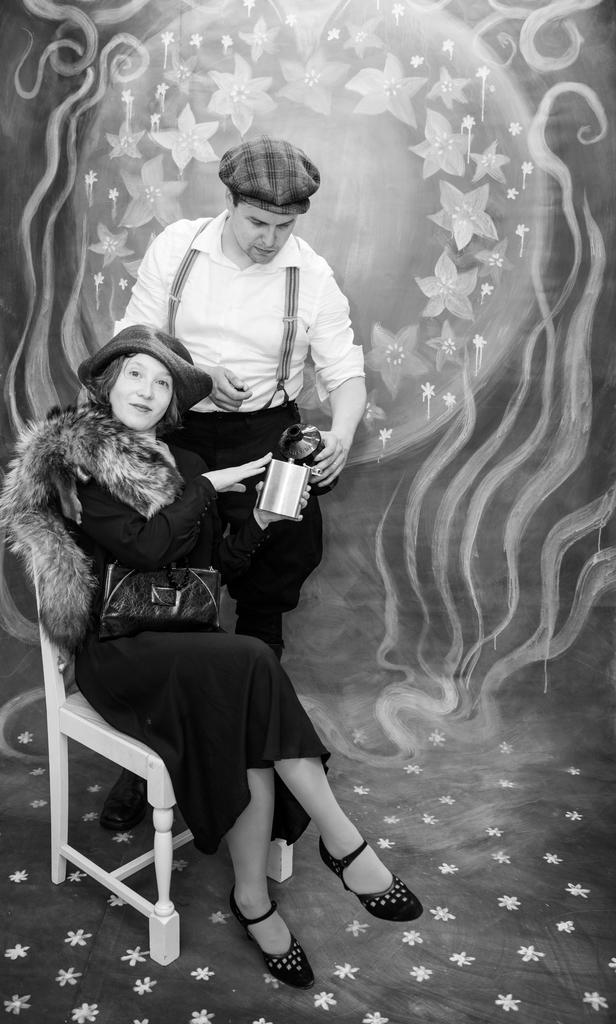What is the color scheme of the image? The image is black and white. What is the woman in the image doing? The woman is sitting on a chair and posing for a photo. Can you describe the man's position in the image? The man is behind the woman in the image. What can be seen in the background of the image? There is artwork visible in the background of the image. Where is the kettle located in the image? There is no kettle present in the image. What type of sofa is visible in the image? There is no sofa present in the image. 